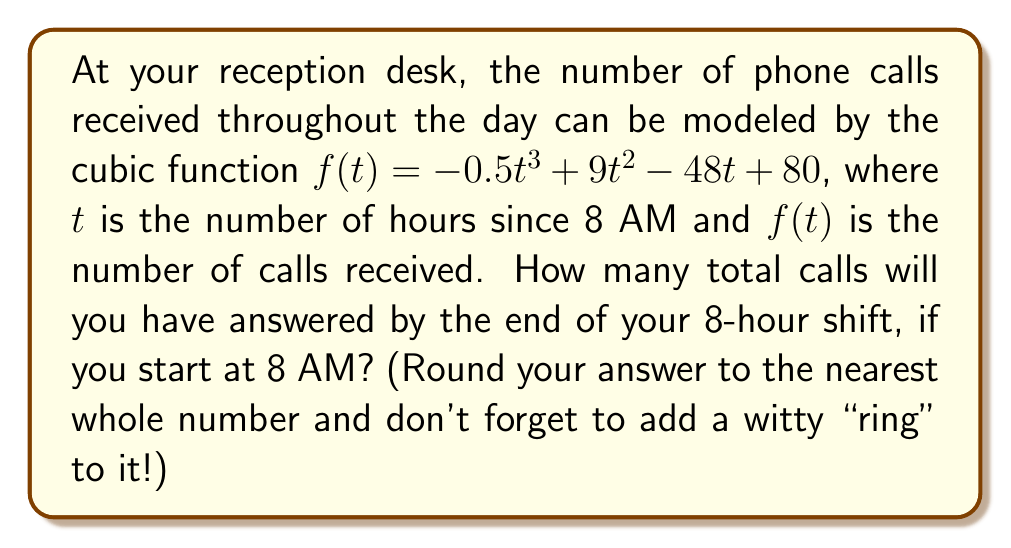Teach me how to tackle this problem. To solve this problem, we need to find the definite integral of the given function from $t=0$ to $t=8$. This will give us the total area under the curve, which represents the total number of calls received during the 8-hour shift.

Step 1: Set up the definite integral
$$\int_0^8 (-0.5t^3 + 9t^2 - 48t + 80) dt$$

Step 2: Integrate the function
$$\left[-\frac{1}{8}t^4 + 3t^3 - 24t^2 + 80t\right]_0^8$$

Step 3: Evaluate the integral at the upper and lower bounds
Upper bound (t=8):
$$-\frac{1}{8}(8^4) + 3(8^3) - 24(8^2) + 80(8) = -256 + 1536 - 1536 + 640 = 384$$

Lower bound (t=0):
$$-\frac{1}{8}(0^4) + 3(0^3) - 24(0^2) + 80(0) = 0$$

Step 4: Subtract the lower bound from the upper bound
$$384 - 0 = 384$$

Step 5: Round to the nearest whole number
384 (already a whole number)
Answer: 384 calls (That's a lot of "ring-ing" in your ears!) 